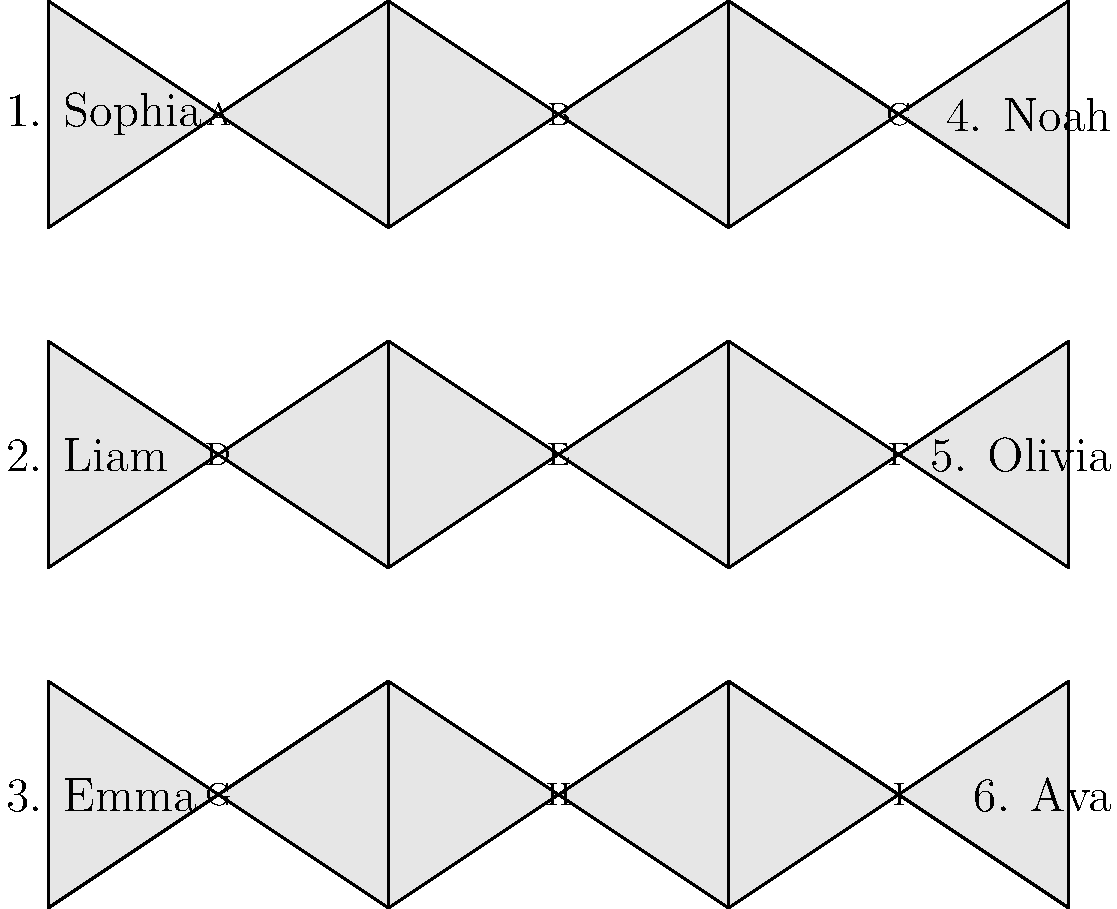Match the following names to their most likely country of origin flags:

1. Sophia
2. Liam
3. Emma
4. Noah
5. Olivia
6. Ava

A. Greece
B. Ireland
C. Germany
D. Israel
E. England
F. United States
G. Italy
H. Scotland
I. France Let's break down the origin of each name and match it to the most likely country:

1. Sophia: This name has Greek origins, meaning "wisdom." It's most closely associated with Greece (Flag A).

2. Liam: This name is an Irish short form of Uilliam (Irish for William). It's most closely associated with Ireland (Flag B).

3. Emma: While popular in many countries, Emma has Germanic origins. It's most closely associated with Germany (Flag C).

4. Noah: This name has Hebrew origins and is common in Jewish communities. It's most closely associated with Israel (Flag D).

5. Olivia: This name has Latin origins but became popular in England through Shakespeare's use. It's most closely associated with England (Flag E).

6. Ava: While it has variations in different cultures, Ava is particularly popular in the United States. It's most closely associated with the United States (Flag F).

The remaining flags represent:
G. Italy
H. Scotland
I. France

These aren't directly matched with the given names but are included to provide additional options and increase the difficulty of the question.
Answer: 1-A, 2-B, 3-C, 4-D, 5-E, 6-F 